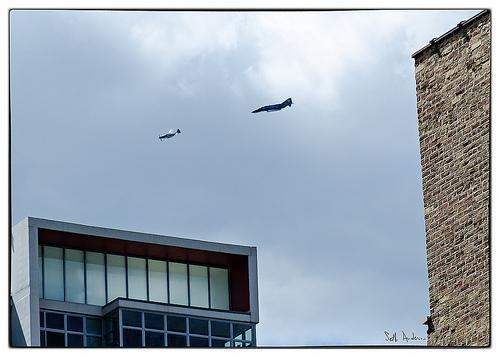How many planes are there?
Give a very brief answer. 2. 